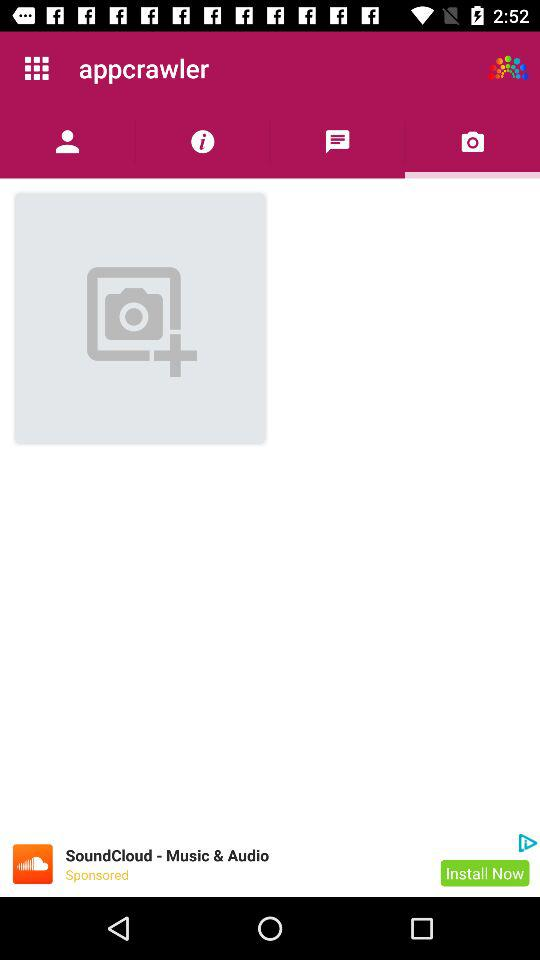Which tab has been selected? The selected tab is "Camera". 